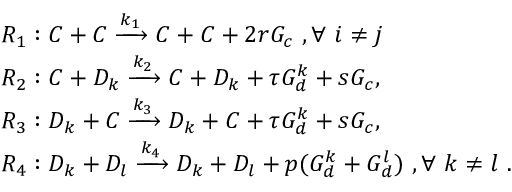Convert formula to latex. <formula><loc_0><loc_0><loc_500><loc_500>\begin{array} { r l } & { R _ { 1 } \colon C + C \xrightarrow { k _ { 1 } } C + C + 2 r G _ { c } , \forall i \ne j } \\ & { R _ { 2 } \colon C + D _ { k } \xrightarrow { k _ { 2 } } C + D _ { k } + \tau G _ { d } ^ { k } + s G _ { c } , } \\ & { R _ { 3 } \colon D _ { k } + C \xrightarrow { k _ { 3 } } D _ { k } + C + \tau G _ { d } ^ { k } + s G _ { c } , } \\ & { R _ { 4 } \colon D _ { k } + D _ { l } \xrightarrow { k _ { 4 } } D _ { k } + D _ { l } + p ( G _ { d } ^ { k } + G _ { d } ^ { l } ) , \forall k \ne l . } \end{array}</formula> 